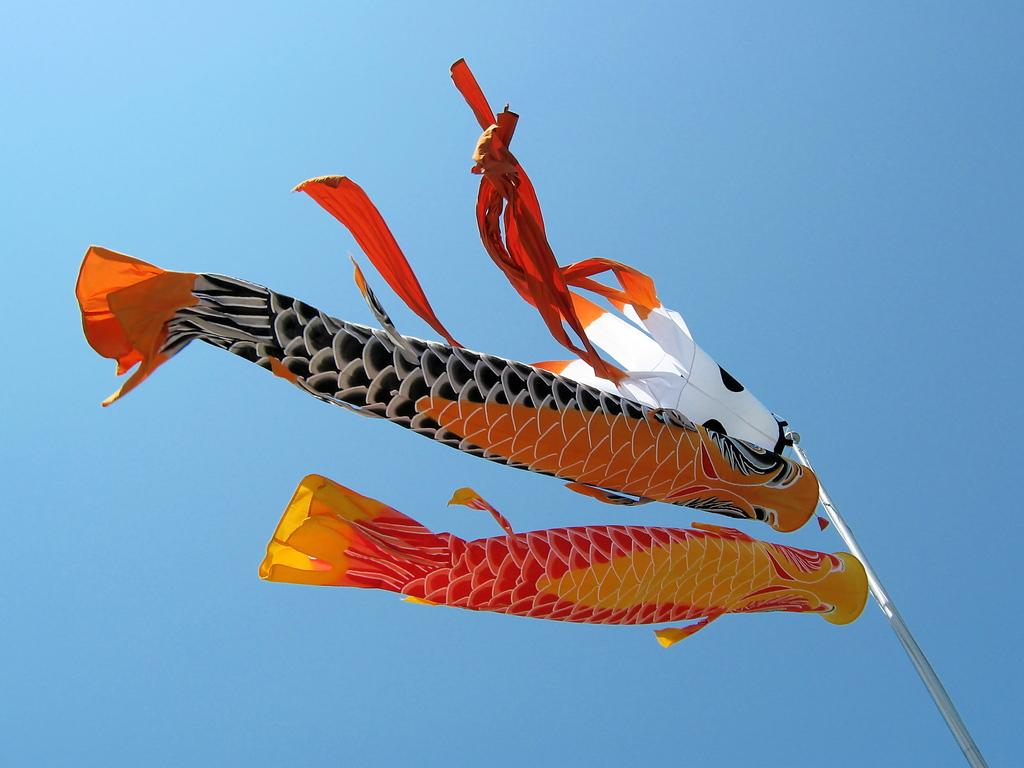What type of objects are present in the image that resemble fish? There are objects in the image that resemble fish. What are these objects doing in the image? These objects are flying in the air. Where are these objects located in the image? The objects are in the sky. What type of design can be seen on the grandmother's basket in the image? There is no grandmother or basket present in the image; it features objects that resemble fish flying in the sky. 